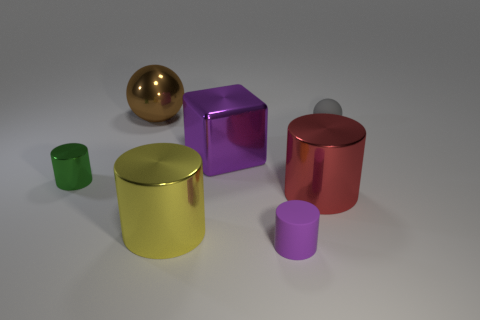Is the number of yellow balls greater than the number of green cylinders?
Offer a very short reply. No. What number of other objects are there of the same material as the tiny purple thing?
Your answer should be very brief. 1. What number of objects are either red metal balls or big metal cylinders that are right of the rubber cylinder?
Offer a terse response. 1. Are there fewer large purple cubes than rubber objects?
Your response must be concise. Yes. What is the color of the small rubber thing behind the metallic cylinder to the left of the brown sphere to the left of the gray rubber sphere?
Your response must be concise. Gray. Are the brown thing and the large yellow cylinder made of the same material?
Provide a short and direct response. Yes. How many brown shiny things are left of the tiny gray object?
Your answer should be very brief. 1. What size is the yellow metal thing that is the same shape as the big red object?
Make the answer very short. Large. What number of brown objects are either tiny rubber cylinders or big spheres?
Offer a very short reply. 1. What number of small shiny objects are in front of the large shiny cylinder that is to the left of the purple metallic block?
Ensure brevity in your answer.  0. 